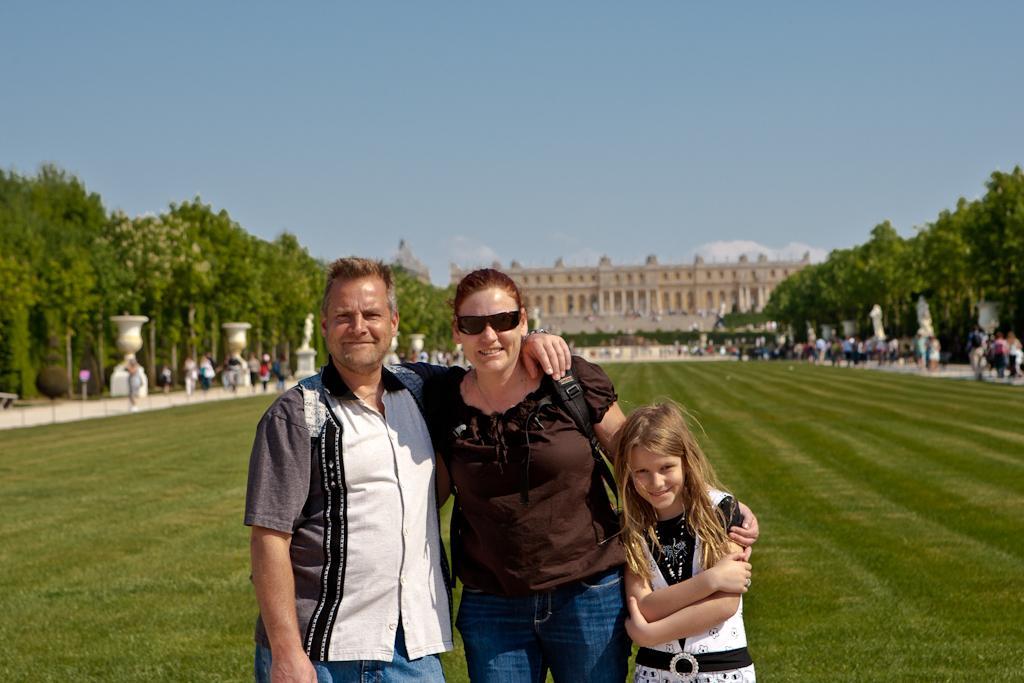How would you summarize this image in a sentence or two? In this image there is grass at the bottom. There are people, sculptures and trees on the left and right corner. There are people in the foreground. There is a building, there are trees and people in the background. And there is sky at the top. 